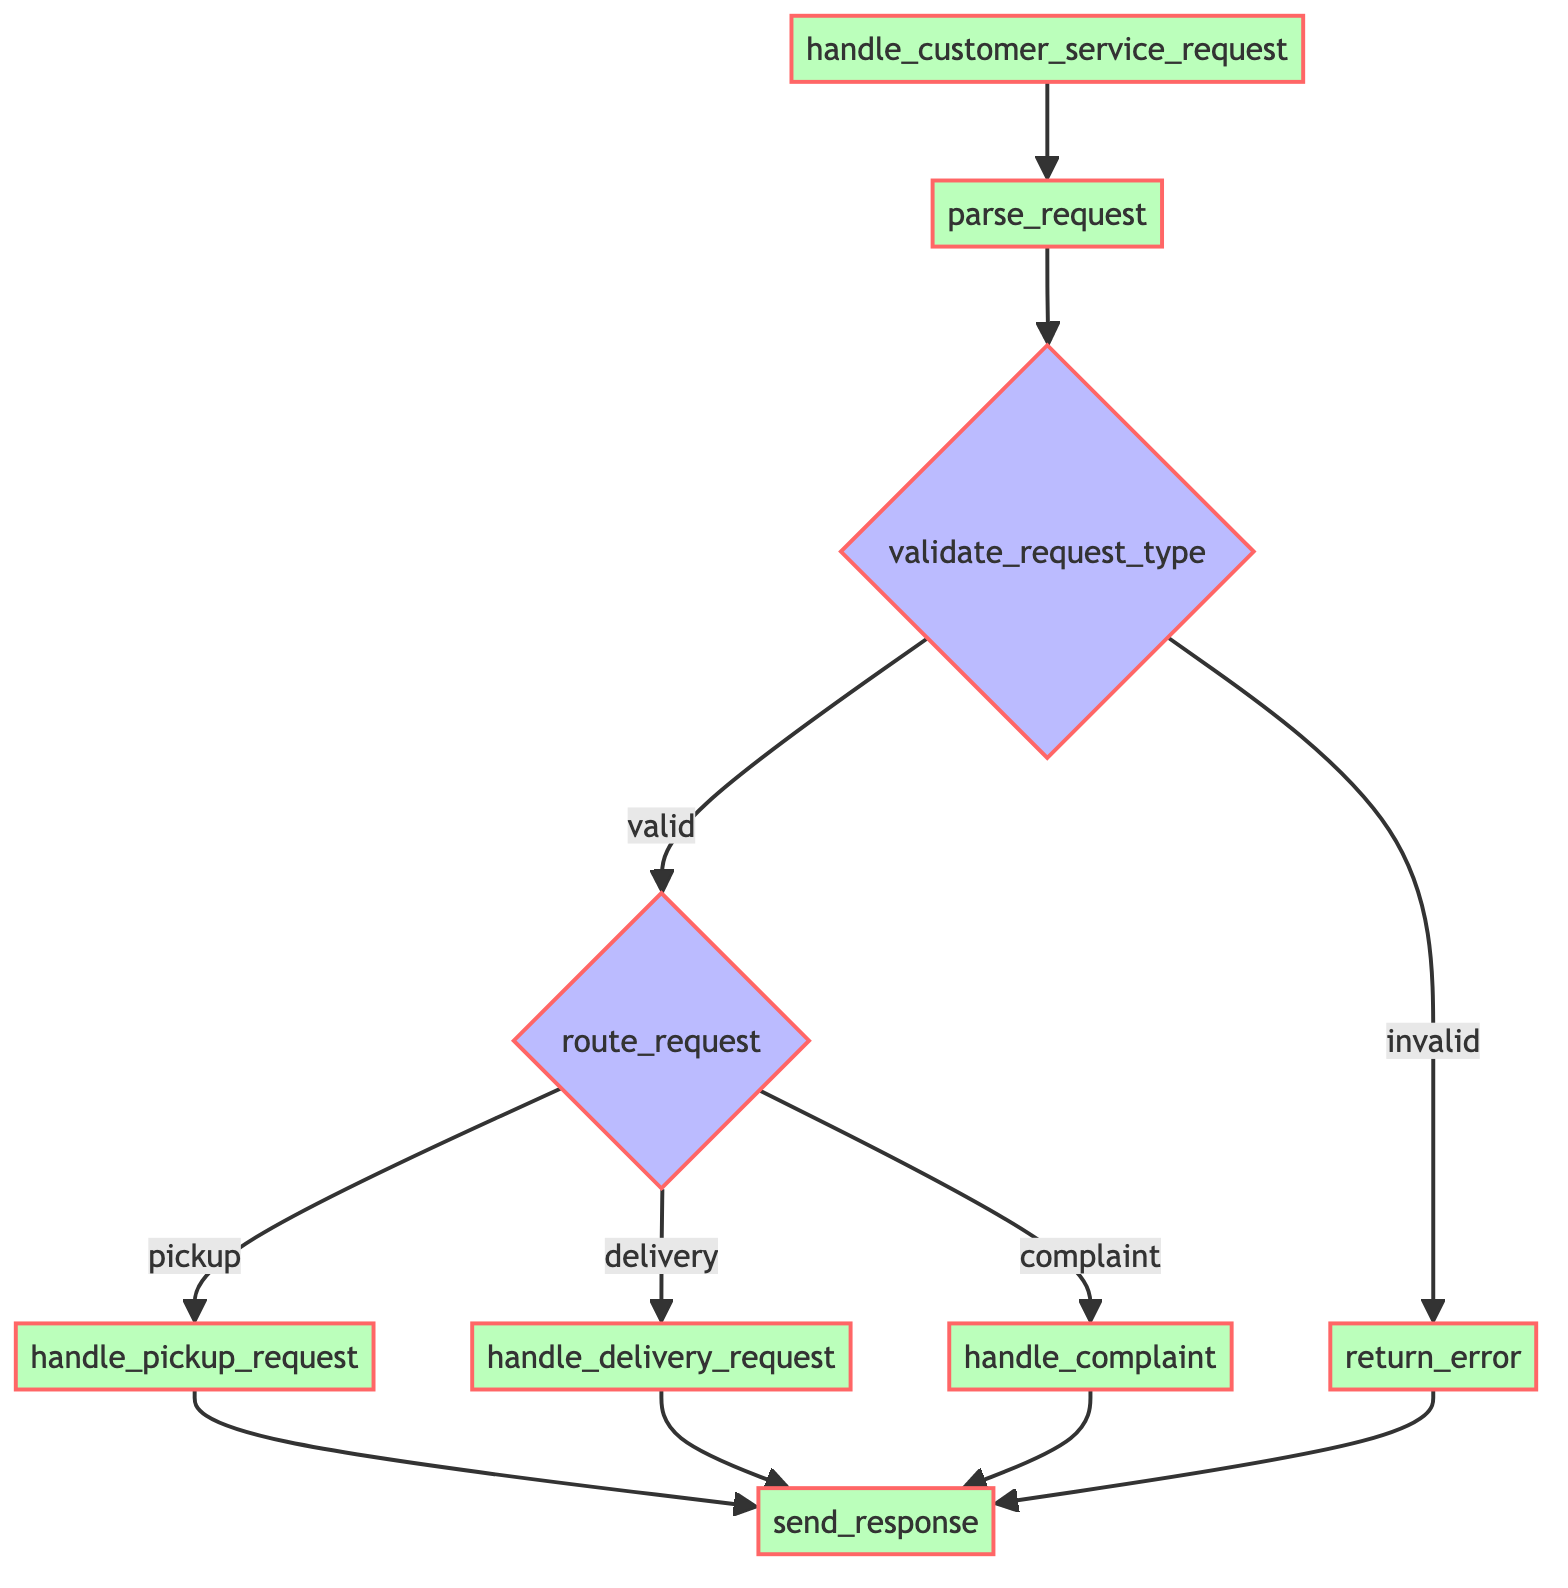what is the first function called in the flowchart? The flowchart starts with the 'handle_customer_service_request' function, which is represented as the first node in the diagram.
Answer: handle_customer_service_request how many decision nodes are in the flowchart? There are two decision nodes in the flowchart: 'validate_request_type' and 'route_request'. Each of these decisions leads to different branches based on their conditions.
Answer: 2 which function is executed if the request type is invalid? If the request type is invalid, the 'return_error' function is executed, as indicated by the branch from 'validate_request_type' when the condition is 'invalid'.
Answer: return_error what are the three request types considered in the flowchart? The three request types considered are 'pickup', 'delivery', and 'complaint', as shown in the branches under the 'route_request' decision node.
Answer: pickup, delivery, complaint what happens after processing a pickup request? After processing a pickup request through the 'handle_pickup_request' function, the flow continues to the 'send_response' function, which indicates a confirmation or resolution being sent to the customer.
Answer: send_response if the request type is valid, how many possible flows can occur? If the request type is valid, there are three possible flows that can occur, corresponding to 'pickup', 'delivery', or 'complaint' routes that are determined by the 'route_request' decision node.
Answer: 3 which function is the last step in all scenarios of the flowchart? In all scenarios, whether the request type is valid or invalid, the last function executed is 'send_response', which finalizes the flow by sending a response back to the customer.
Answer: send_response 